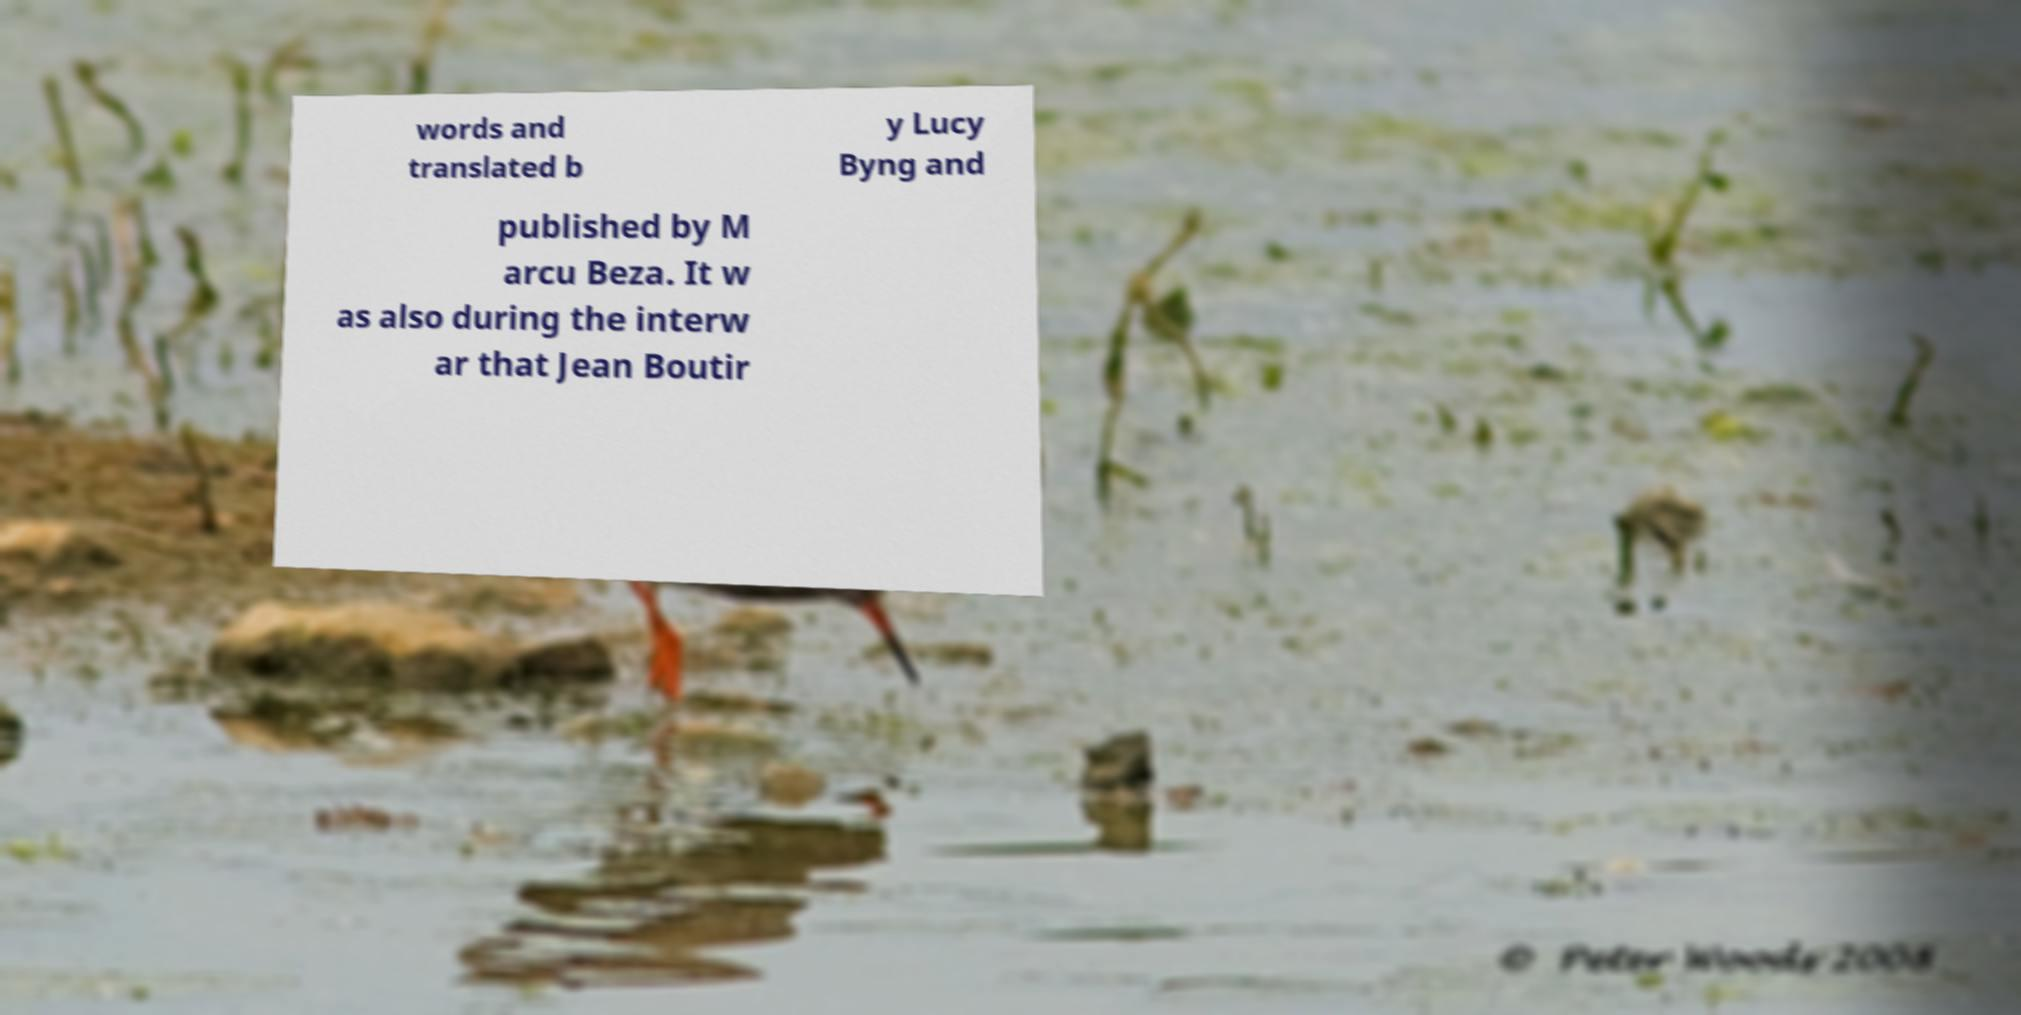There's text embedded in this image that I need extracted. Can you transcribe it verbatim? words and translated b y Lucy Byng and published by M arcu Beza. It w as also during the interw ar that Jean Boutir 